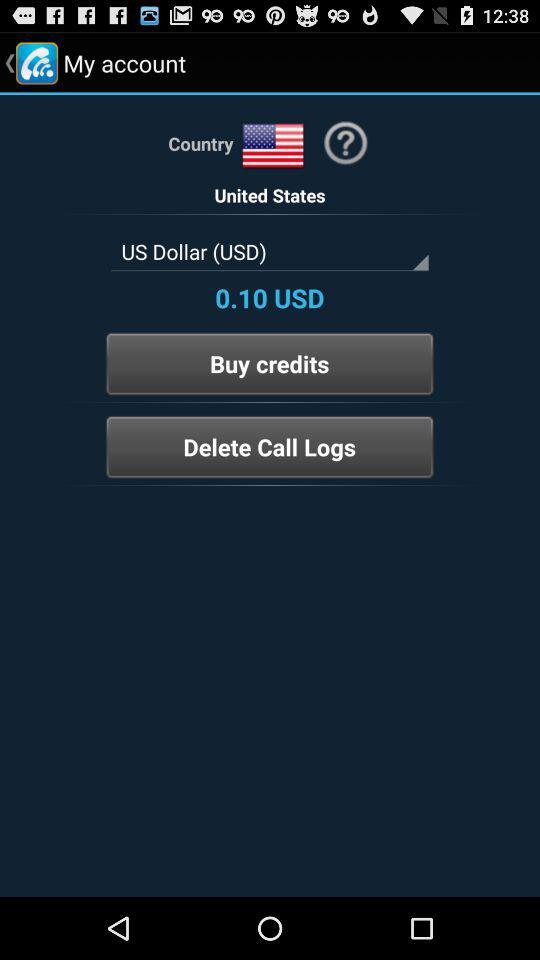How much is the amount in USD? The amount in USD is 0.10. 